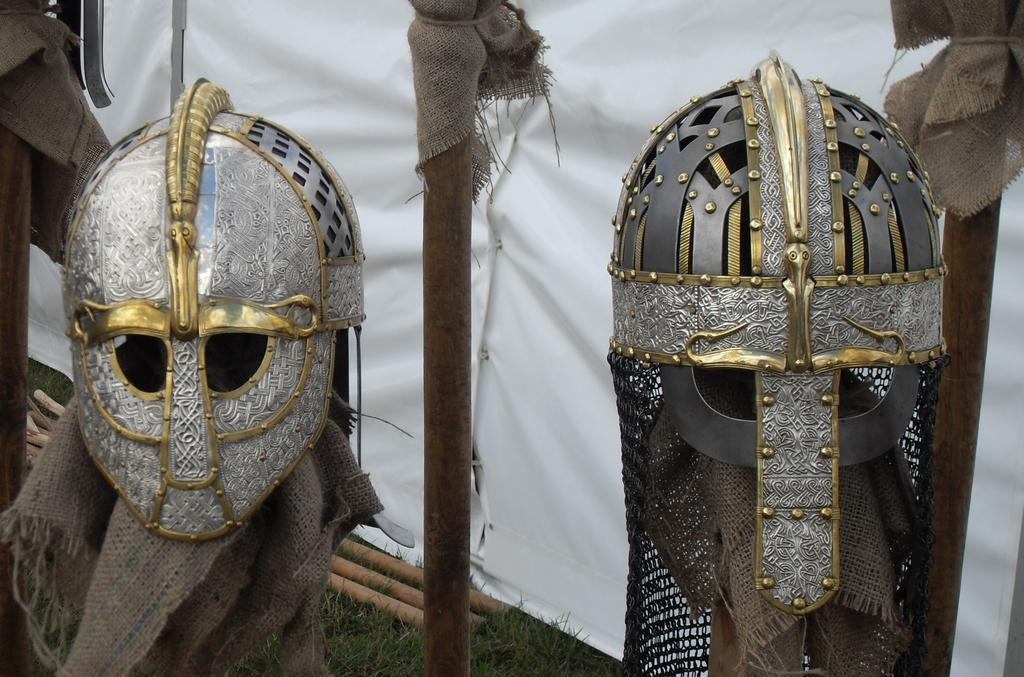What type of object is present in the image? There is a cloth in the image. What other objects can be seen in the image? There are helmets in the image. What type of stone is present in the image? There is no stone present in the image. What statement or argument can be seen in the image? There is no statement or argument present in the image. 